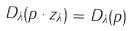Convert formula to latex. <formula><loc_0><loc_0><loc_500><loc_500>D _ { \lambda } ( p \cdot z _ { \lambda } ) = D _ { \lambda } ( p )</formula> 